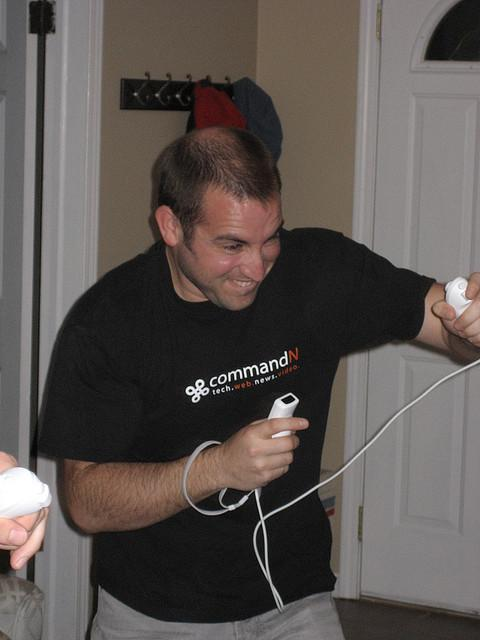What is wrapped around his wrist? Please explain your reasoning. cord. The cord is connected to the wii remote, and it is wrapped around his wrist so that the remote does not fall if he lets go of it. 